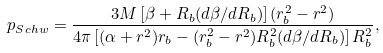Convert formula to latex. <formula><loc_0><loc_0><loc_500><loc_500>p _ { S c h w } = \frac { 3 M \left [ \beta + R _ { b } ( d \beta / d R _ { b } ) \right ] ( r _ { b } ^ { 2 } - r ^ { 2 } ) } { 4 \pi \left [ ( \alpha + r ^ { 2 } ) r _ { b } - ( r _ { b } ^ { 2 } - r ^ { 2 } ) R _ { b } ^ { 2 } ( d \beta / d R _ { b } ) \right ] R _ { b } ^ { 2 } } ,</formula> 